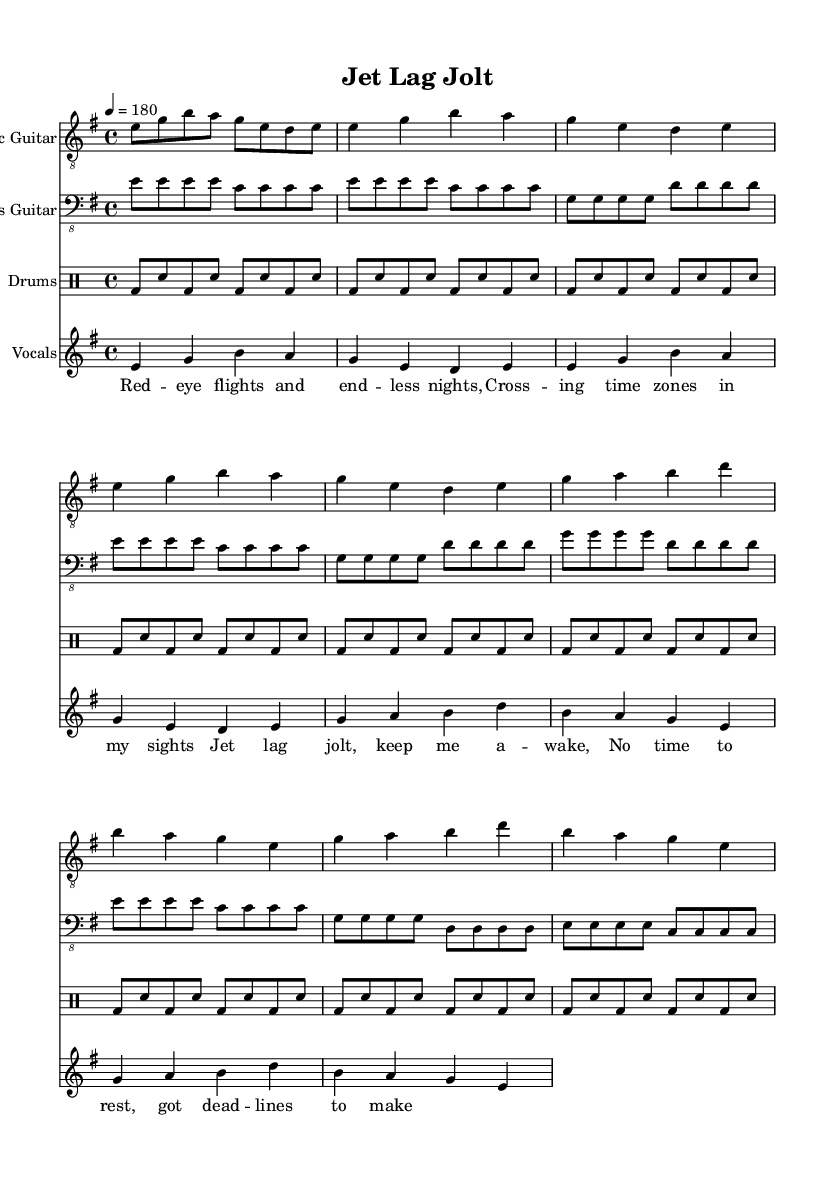What is the key signature of this music? The key signature is E minor, which has one sharp (F#). This can be identified by looking at the key signature indicated at the beginning of the sheet music, before the time signature.
Answer: E minor What is the time signature of this music? The time signature is 4/4, meaning there are four beats in each measure and the quarter note gets the beat. This is evident from the time signature notation shown early in the sheet music.
Answer: 4/4 What is the tempo of the piece? The tempo is marked at 180 beats per minute. This is stated at the beginning of the music, indicating how fast the music should be played.
Answer: 180 How many measures are there in the verse section? The verse section contains 8 measures. Each measure is separated by vertical lines, and counting the measures in the verse part confirms this.
Answer: 8 Which instrument part has the introduction written with eighth notes? The electric guitar part has the introduction written with eighth notes. This is identifiable by looking at the rhythmic notation where the intro starts with e8 g b a g e d e.
Answer: Electric Guitar What lyrical theme is expressed in the chorus? The chorus expresses a theme of urgency and energy related to jet lag and deadlines. By analyzing the lyrics, we see that it focuses on staying awake and managing time despite travel fatigue.
Answer: Urgency How is the drumming pattern characterized in the verse section? The drumming pattern in the verse is characterized by a consistent bass drum and snare pattern, played in eighth notes, maintaining a high-energy feel throughout. This can be seen in the drum part where bass and snare are alternated.
Answer: Consistent 